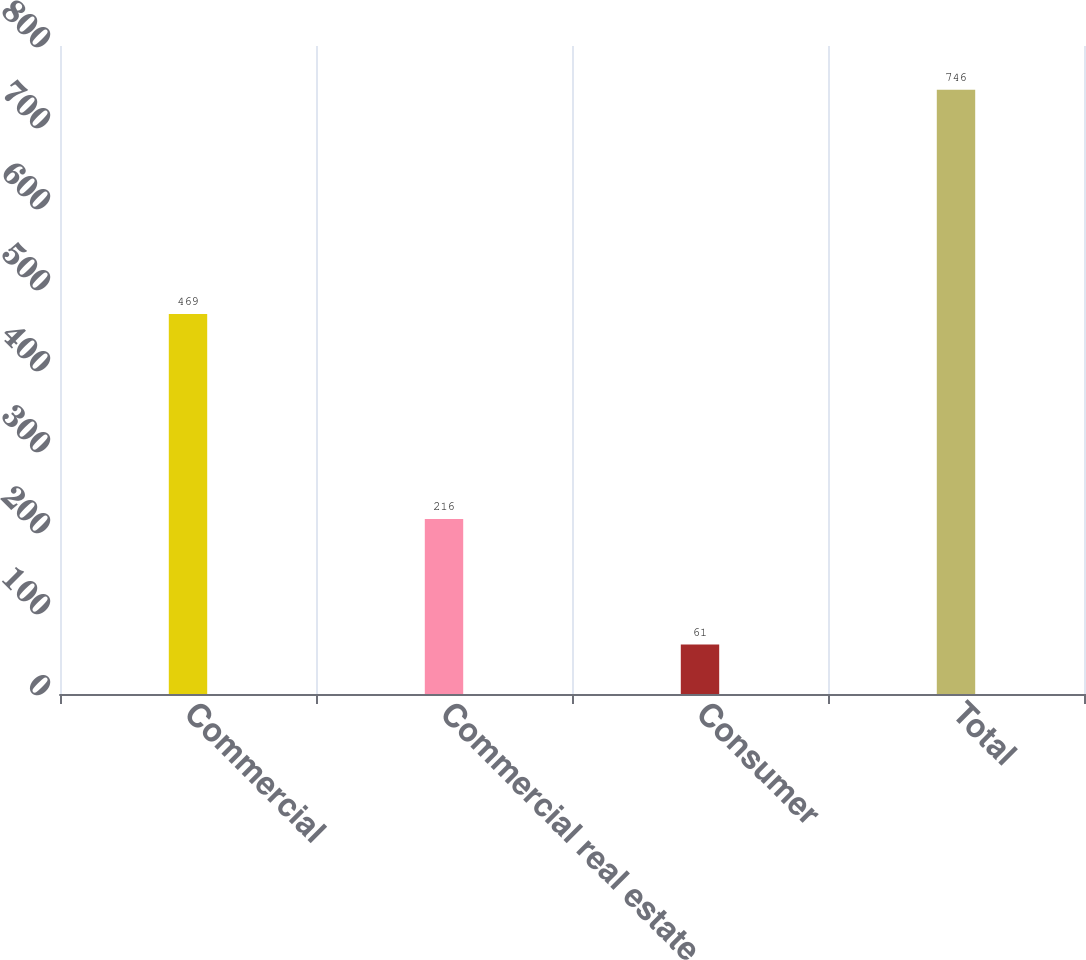Convert chart to OTSL. <chart><loc_0><loc_0><loc_500><loc_500><bar_chart><fcel>Commercial<fcel>Commercial real estate<fcel>Consumer<fcel>Total<nl><fcel>469<fcel>216<fcel>61<fcel>746<nl></chart> 